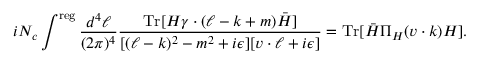Convert formula to latex. <formula><loc_0><loc_0><loc_500><loc_500>i N _ { c } \int ^ { r e g } \frac { d ^ { 4 } \ell } { ( 2 \pi ) ^ { 4 } } \frac { T r [ H \gamma \cdot ( \ell - k + m ) \bar { H } ] } { [ ( \ell - k ) ^ { 2 } - m ^ { 2 } + i \epsilon ] [ v \cdot \ell + i \epsilon ] } = T r [ \bar { H } \Pi _ { H } ( v \cdot k ) H ] .</formula> 